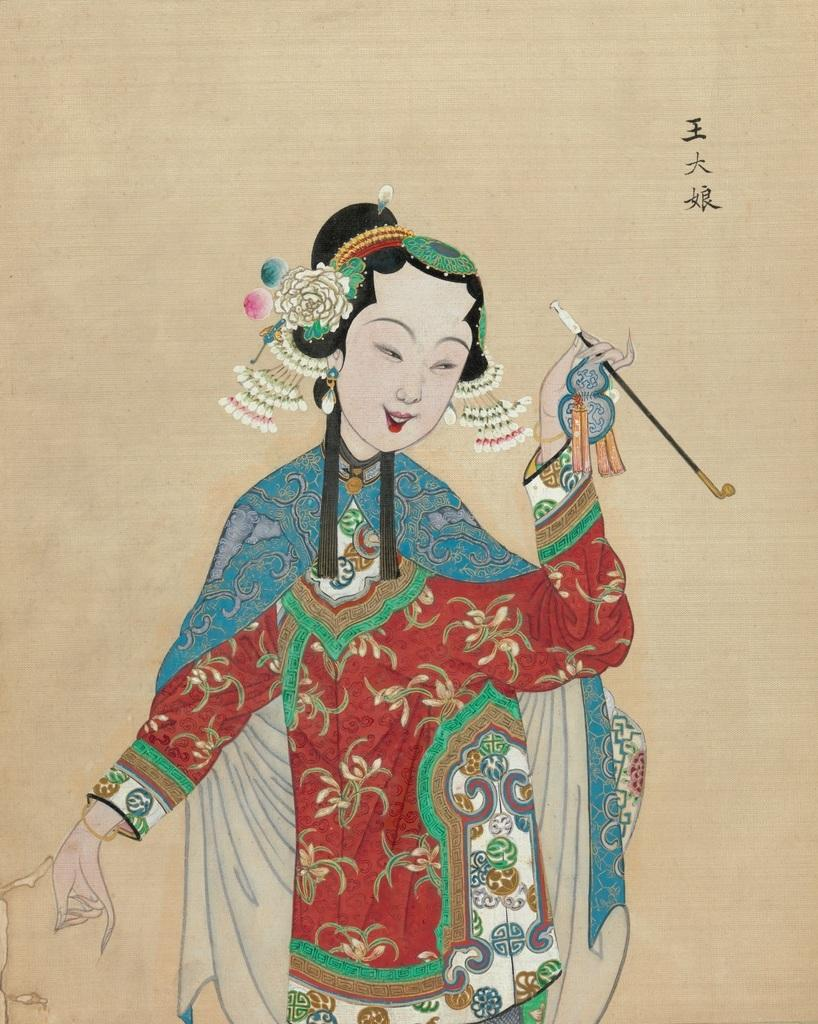What is the main subject of the image? There is a painting in the image. What is depicted in the painting? The painting depicts a woman. What is the woman holding in the painting? The woman is holding an object in the painting. Can you describe the object the woman is holding? The object is on a paper in the painting. How many pigs can be seen swimming in the waves near the woman in the painting? There are no pigs or waves present in the painting; it depicts a woman holding an object on a paper. 